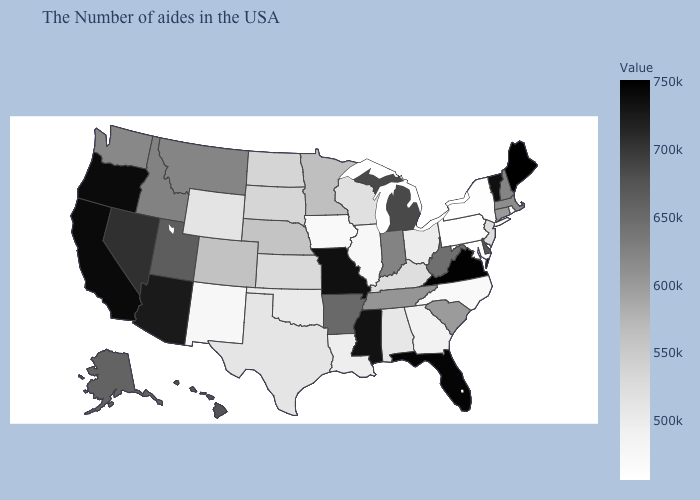Among the states that border New York , which have the lowest value?
Concise answer only. Pennsylvania. Is the legend a continuous bar?
Give a very brief answer. Yes. Does Delaware have the lowest value in the South?
Write a very short answer. No. 